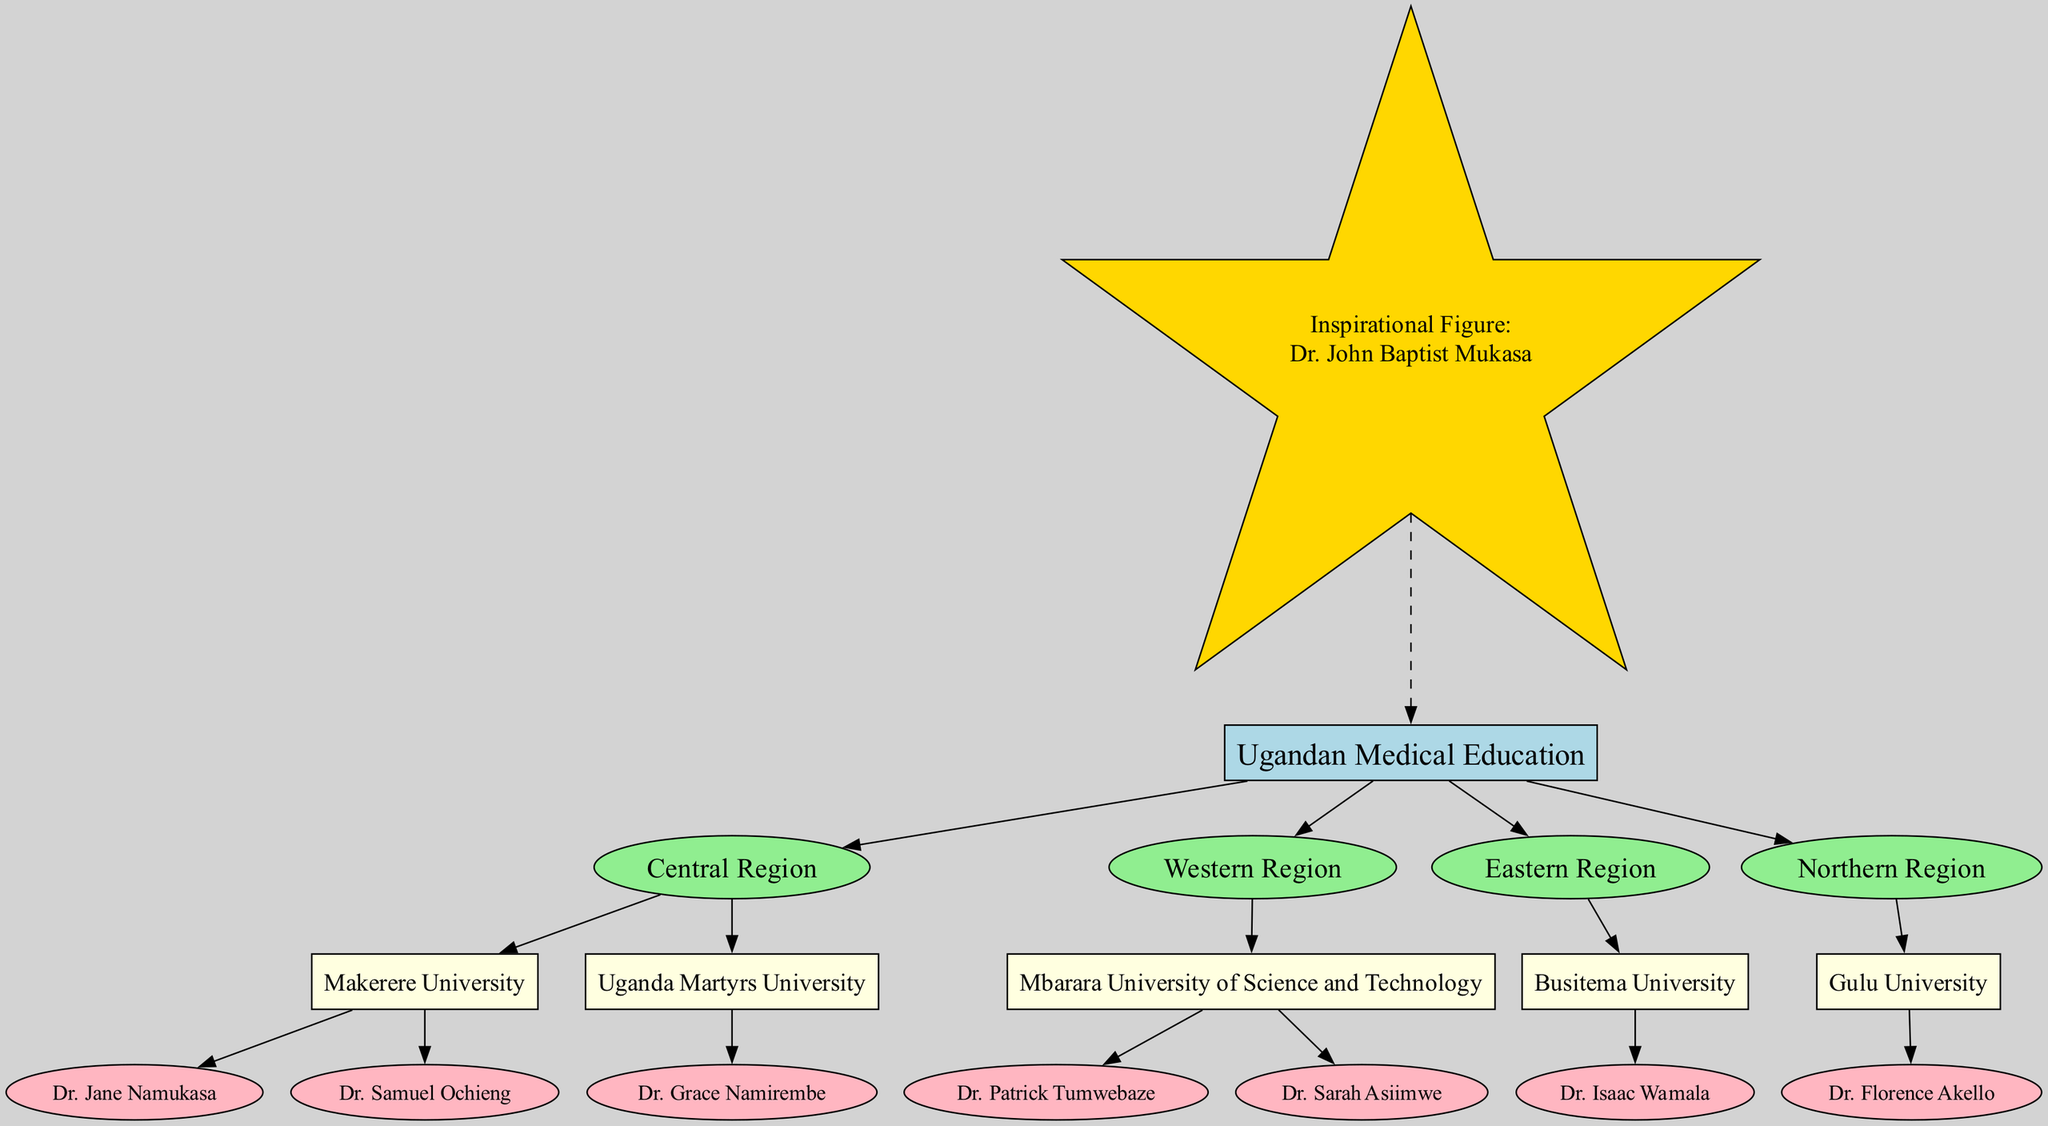What is the root of the family tree? The root node of the tree is labeled as "Ugandan Medical Education", which represents the overall theme of the diagram.
Answer: Ugandan Medical Education What university has the most graduates? Upon inspecting the universities listed under the branches, Makerere University has two graduates (Dr. Jane Namukasa and Dr. Samuel Ochieng), which is the highest number compared to the other universities.
Answer: Makerere University How many regions are represented in the family tree? By counting the branches in the tree, there are four regions listed: Central Region, Western Region, Eastern Region, and Northern Region.
Answer: Four Who graduated from Uganda Martyrs University? Looking at the branch for Uganda Martyrs University, it shows that Dr. Grace Namirembe is the only graduate listed there.
Answer: Dr. Grace Namirembe What is the relationship between Gulu University and the Northern Region? Gulu University is listed as a child of the Northern Region, indicating that it belongs to this specific geographical area in Uganda.
Answer: Gulu University How many graduates are there in total across all universities? To find the total number of graduates, we need to add them up: Makerere University has 2, Uganda Martyrs University has 1, Mbarara University has 2, Busitema University has 1, and Gulu University has 1. This sums up to a total of 7 graduates.
Answer: Seven Which university has the least number of graduates? In checking the list, Busitema University has only one graduate (Dr. Isaac Wamala), which is the least amount compared to other universities.
Answer: Busitema University What shape represents the inspirational figure in the diagram? The diagram indicates that the inspirational figure, Dr. John Baptist Mukasa, is represented using a star shape, which is visually distinct from the other types of nodes.
Answer: Star Which two graduates come from Mbarara University of Science and Technology? Upon examination of the branch for Mbarara University of Science and Technology, the graduates listed are Dr. Patrick Tumwebaze and Dr. Sarah Asiimwe.
Answer: Dr. Patrick Tumwebaze and Dr. Sarah Asiimwe 